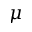Convert formula to latex. <formula><loc_0><loc_0><loc_500><loc_500>\mu</formula> 